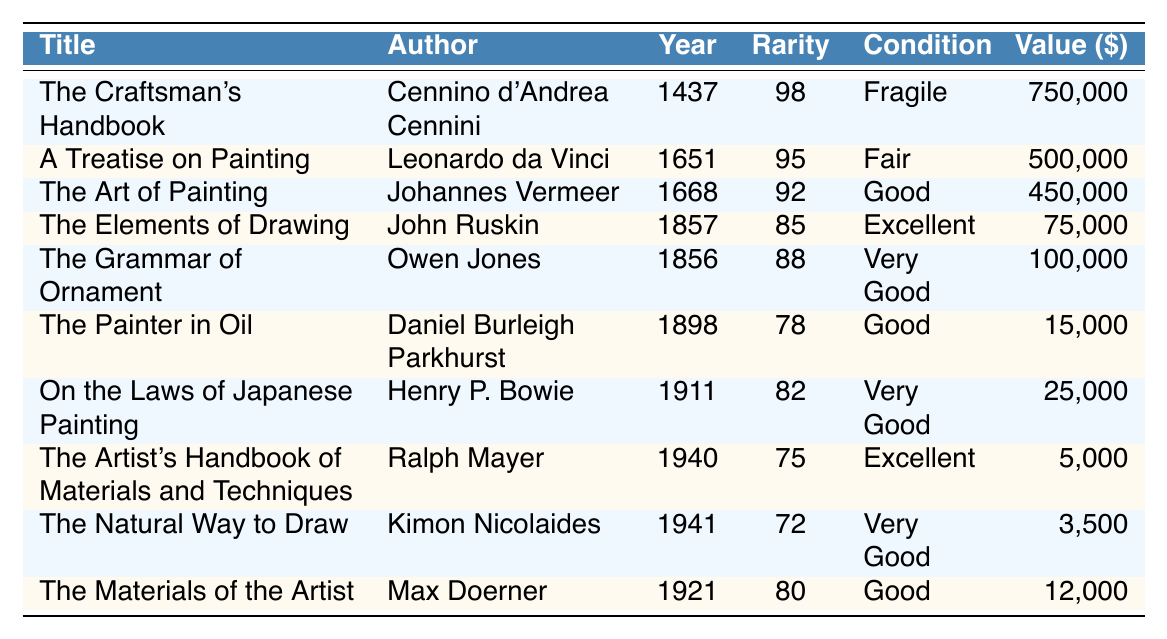What is the title of the book with the highest rarity score? The highest rarity score in the table is 98, which corresponds to "The Craftsman's Handbook."
Answer: The Craftsman's Handbook Which author wrote "The Materials of the Artist"? Looking at the table, "The Materials of the Artist" is listed under the author Max Doerner.
Answer: Max Doerner How many books in the list have a rarity score above 80? The books with rarity scores above 80 are: "The Craftsman's Handbook" (98), "A Treatise on Painting" (95), "The Art of Painting" (92), "The Grammar of Ornament" (88), "The Elements of Drawing" (85), and "On the Laws of Japanese Painting" (82). Counting these gives 6 books.
Answer: 6 What is the estimated value of "The Artist's Handbook of Materials and Techniques"? The table states that the estimated value of "The Artist's Handbook of Materials and Techniques" is $5,000.
Answer: $5,000 Which book was published first, "The Grammar of Ornament" or "The Elements of Drawing"? By checking the publication dates, "The Grammar of Ornament" was published in 1856 and "The Elements of Drawing" in 1857. Since 1856 is earlier than 1857, "The Grammar of Ornament" is the earlier book.
Answer: The Grammar of Ornament Is "The Painter in Oil" in good condition? The table notes that "The Painter in Oil" is in good condition.
Answer: Yes What is the average estimated value of the books published before 1900? The books published before 1900 and their estimated values are: "The Craftsman's Handbook" ($750,000), "A Treatise on Painting" ($500,000), "The Art of Painting" ($450,000), "The Grammar of Ornament" ($100,000), "The Elements of Drawing" ($75,000), "The Painter in Oil" ($15,000), and "On the Laws of Japanese Painting" ($25,000). Summing these gives $750,000 + $500,000 + $450,000 + $100,000 + $75,000 + $15,000 + $25,000 = $1,915,000. There are 7 books, so the average is $1,915,000 / 7 = $273,571.43.
Answer: $273,571.43 Which book has the lowest rarity score and what is that score? The table shows that "The Natural Way to Draw" has the lowest rarity score of 72.
Answer: 72 Are there any books authored by John Ruskin or Kimon Nicolaides? Yes, "The Elements of Drawing" is authored by John Ruskin, and "The Natural Way to Draw" is authored by Kimon Nicolaides, both mentioned in the table.
Answer: Yes What is the difference in estimated value between the highest and lowest valued books? The highest valued book is "The Craftsman's Handbook" at $750,000, and the lowest is "The Natural Way to Draw" at $3,500. The difference is $750,000 - $3,500 = $746,500.
Answer: $746,500 